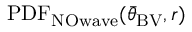<formula> <loc_0><loc_0><loc_500><loc_500>P D F _ { N O w a v e } ( { \bar { \theta } } _ { B V } , r )</formula> 